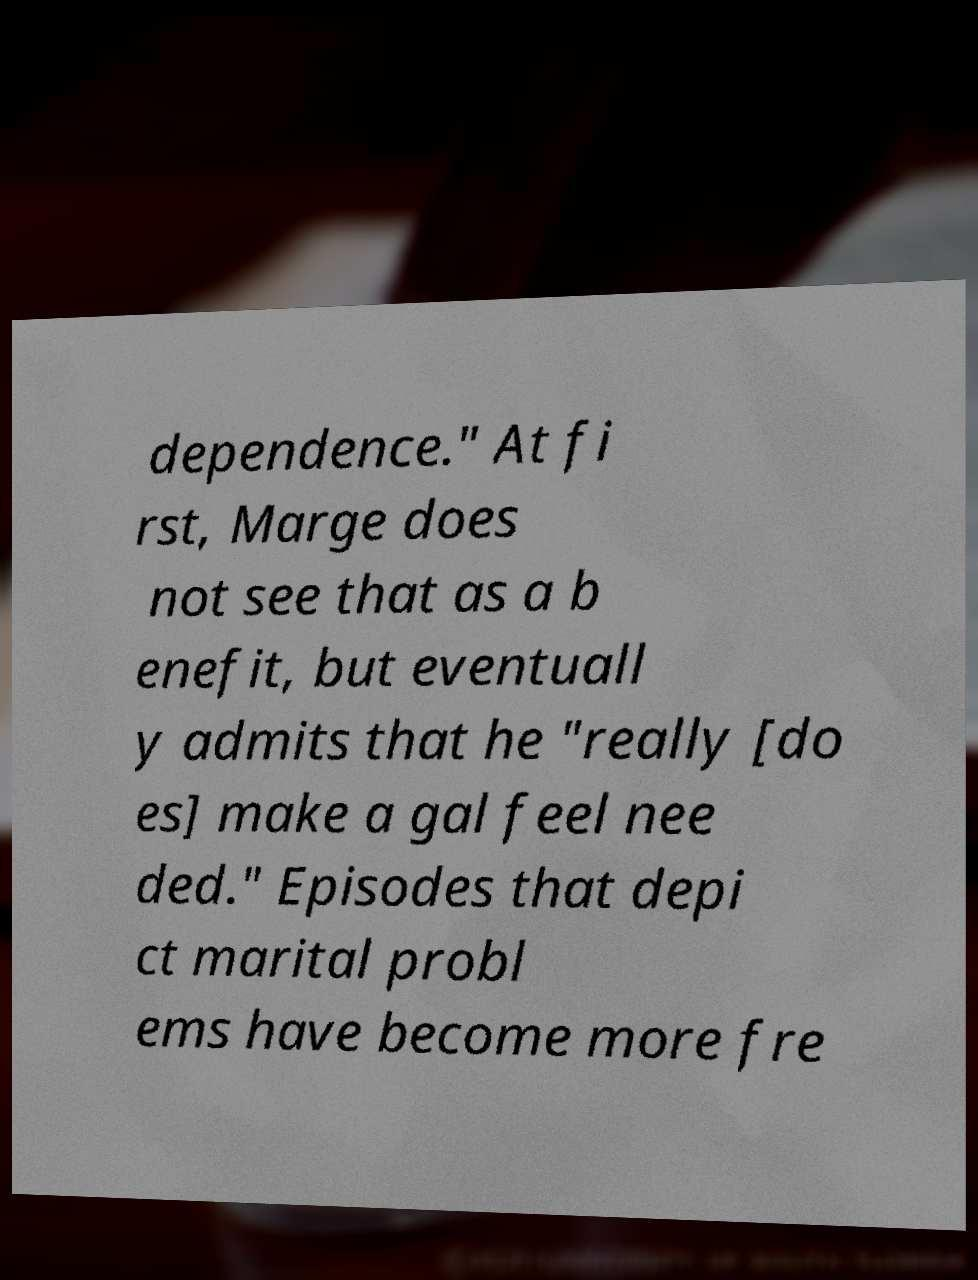Could you assist in decoding the text presented in this image and type it out clearly? dependence." At fi rst, Marge does not see that as a b enefit, but eventuall y admits that he "really [do es] make a gal feel nee ded." Episodes that depi ct marital probl ems have become more fre 